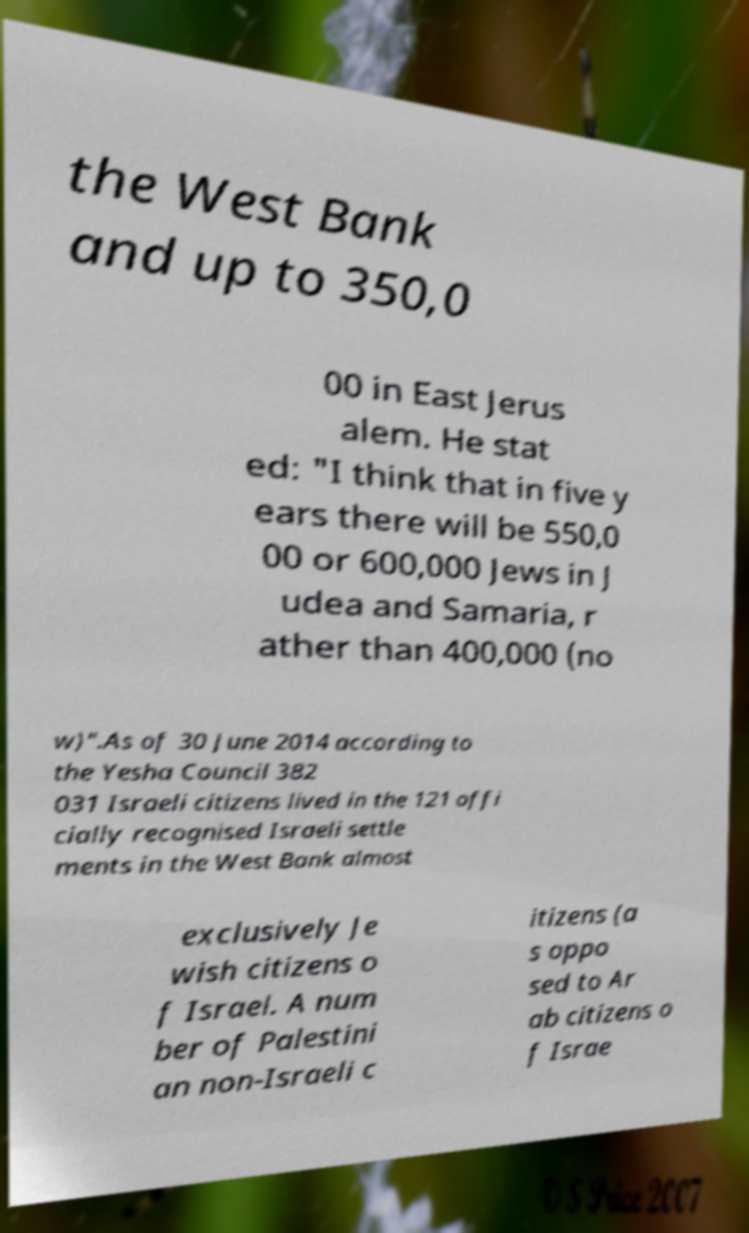Please read and relay the text visible in this image. What does it say? the West Bank and up to 350,0 00 in East Jerus alem. He stat ed: "I think that in five y ears there will be 550,0 00 or 600,000 Jews in J udea and Samaria, r ather than 400,000 (no w)".As of 30 June 2014 according to the Yesha Council 382 031 Israeli citizens lived in the 121 offi cially recognised Israeli settle ments in the West Bank almost exclusively Je wish citizens o f Israel. A num ber of Palestini an non-Israeli c itizens (a s oppo sed to Ar ab citizens o f Israe 